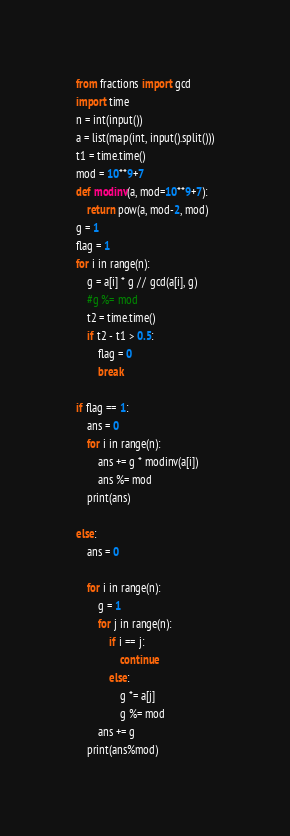<code> <loc_0><loc_0><loc_500><loc_500><_Python_>from fractions import gcd
import time
n = int(input())
a = list(map(int, input().split()))
t1 = time.time()
mod = 10**9+7
def modinv(a, mod=10**9+7):
    return pow(a, mod-2, mod)
g = 1
flag = 1
for i in range(n):
    g = a[i] * g // gcd(a[i], g)
    #g %= mod
    t2 = time.time()
    if t2 - t1 > 0.5:
        flag = 0
        break

if flag == 1:
    ans = 0
    for i in range(n):
        ans += g * modinv(a[i])
        ans %= mod
    print(ans)

else:
    ans = 0

    for i in range(n):
        g = 1
        for j in range(n):
            if i == j:
                continue
            else:
                g *= a[j]
                g %= mod
        ans += g
    print(ans%mod)
</code> 